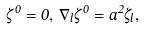<formula> <loc_0><loc_0><loc_500><loc_500>\dot { \zeta } ^ { 0 } = 0 , \, \nabla _ { l } \zeta ^ { 0 } = a ^ { 2 } \dot { \zeta } _ { l } ,</formula> 